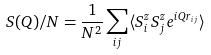Convert formula to latex. <formula><loc_0><loc_0><loc_500><loc_500>S ( Q ) / N = \frac { 1 } { N ^ { 2 } } \sum _ { i j } \langle S ^ { z } _ { i } S ^ { z } _ { j } e ^ { i Q r _ { i j } } \rangle</formula> 